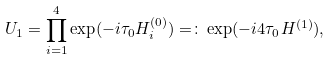Convert formula to latex. <formula><loc_0><loc_0><loc_500><loc_500>U _ { 1 } = \prod _ { i = 1 } ^ { 4 } \exp ( - i \tau _ { 0 } H _ { i } ^ { ( 0 ) } ) = \colon \exp ( - i 4 \tau _ { 0 } H ^ { ( 1 ) } ) ,</formula> 